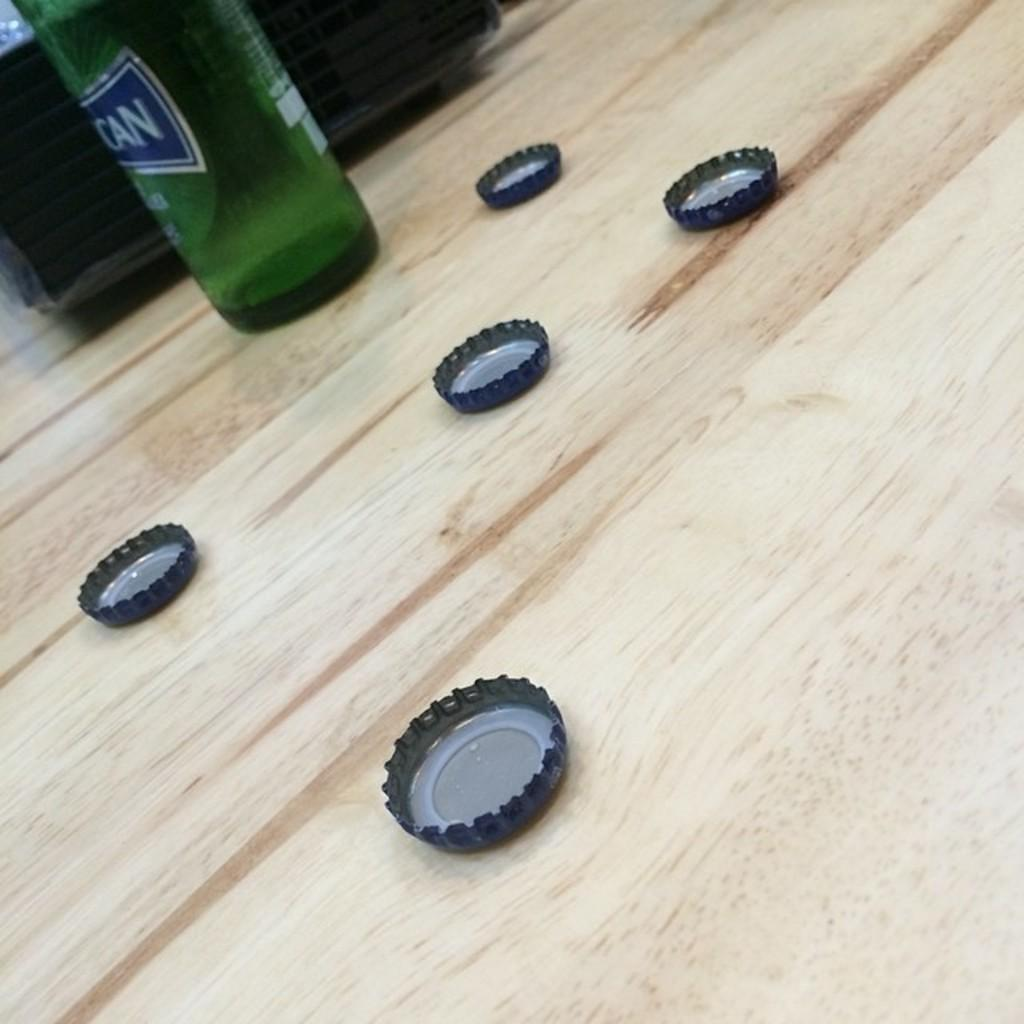What type of bottle is in the image? There is a green glass bottle in the image. What material are the caps in the image made of? The caps in the image are made of metal. Where are the metal caps located in the image? The metal caps are placed on a wooden table. What song is being played in the background of the image? There is no information about a song being played in the image. 